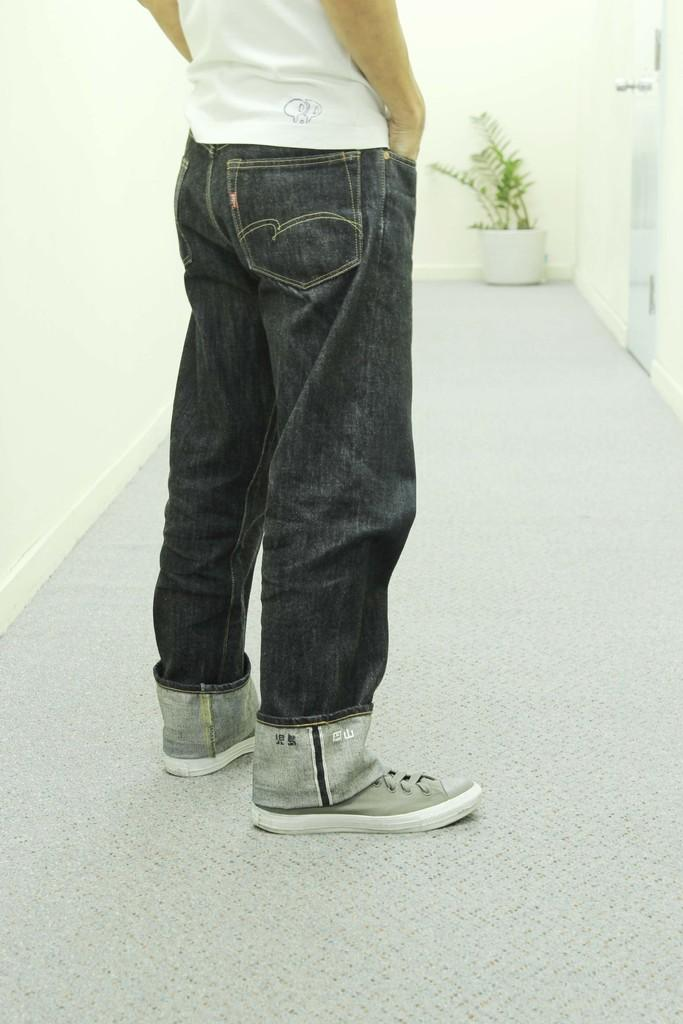Who or what is present in the image? There is a person in the image. What type of object can be seen in the image besides the person? There is a house plant in the image. What color is the wall that is visible in the image? There is a white color wall in the image. What type of button can be seen on the person's shirt in the image? There is no button visible on the person's shirt in the image. Can you hear the sun in the image? The image is a visual representation, and there is no sound or voice present, including the sun. 